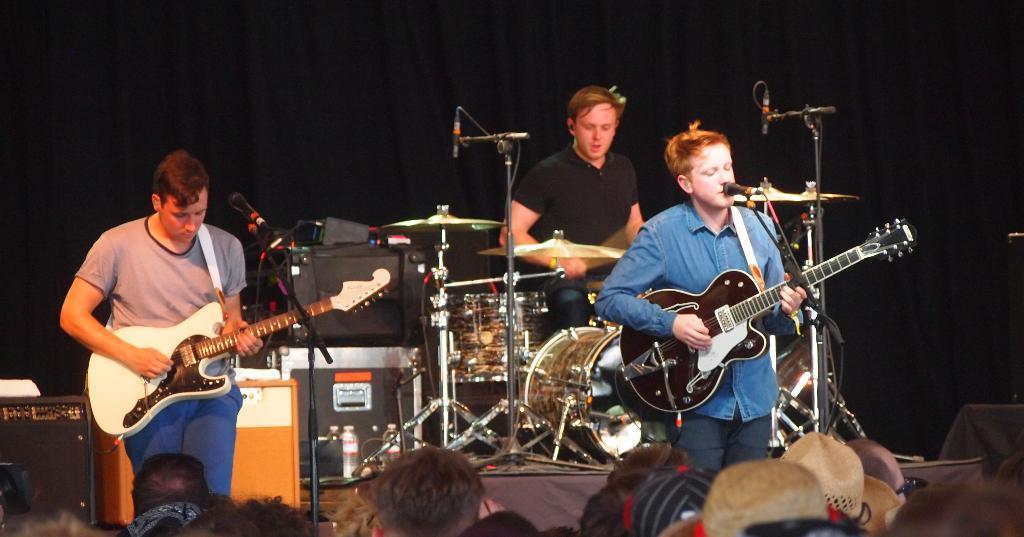In one or two sentences, can you explain what this image depicts? In this image there are three people on stage two are playing guitar and one is playing drums and in the middle of the there is a speaker, drums and there is a microphone and at the bottom there are audience and at the back there is a black curtain. 